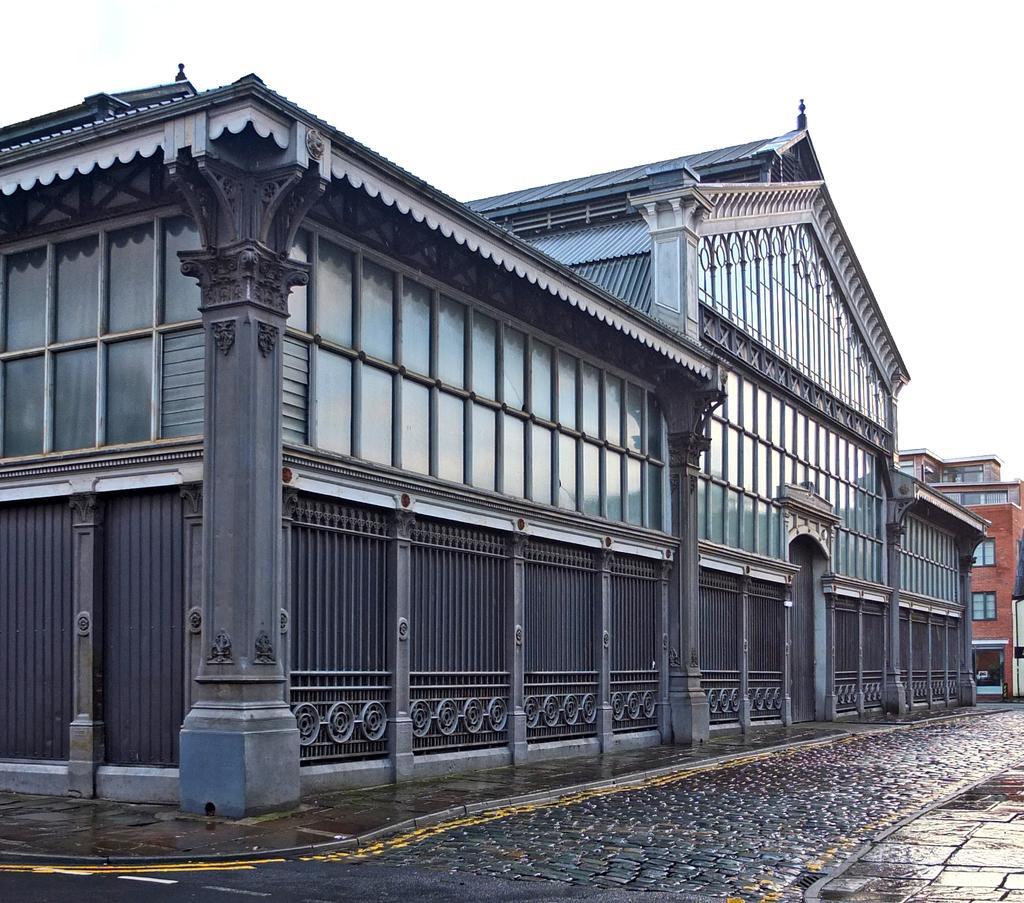Please provide a concise description of this image. In this image, there are a few buildings. We can see the ground and the sky. 